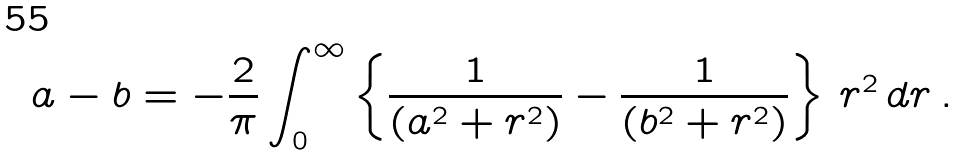Convert formula to latex. <formula><loc_0><loc_0><loc_500><loc_500>a - b = - \frac { 2 } { \pi } \int _ { 0 } ^ { \infty } \left \{ \frac { 1 } { ( a ^ { 2 } + r ^ { 2 } ) } - \frac { 1 } { ( b ^ { 2 } + r ^ { 2 } ) } \right \} \, r ^ { 2 } \, d r \, .</formula> 